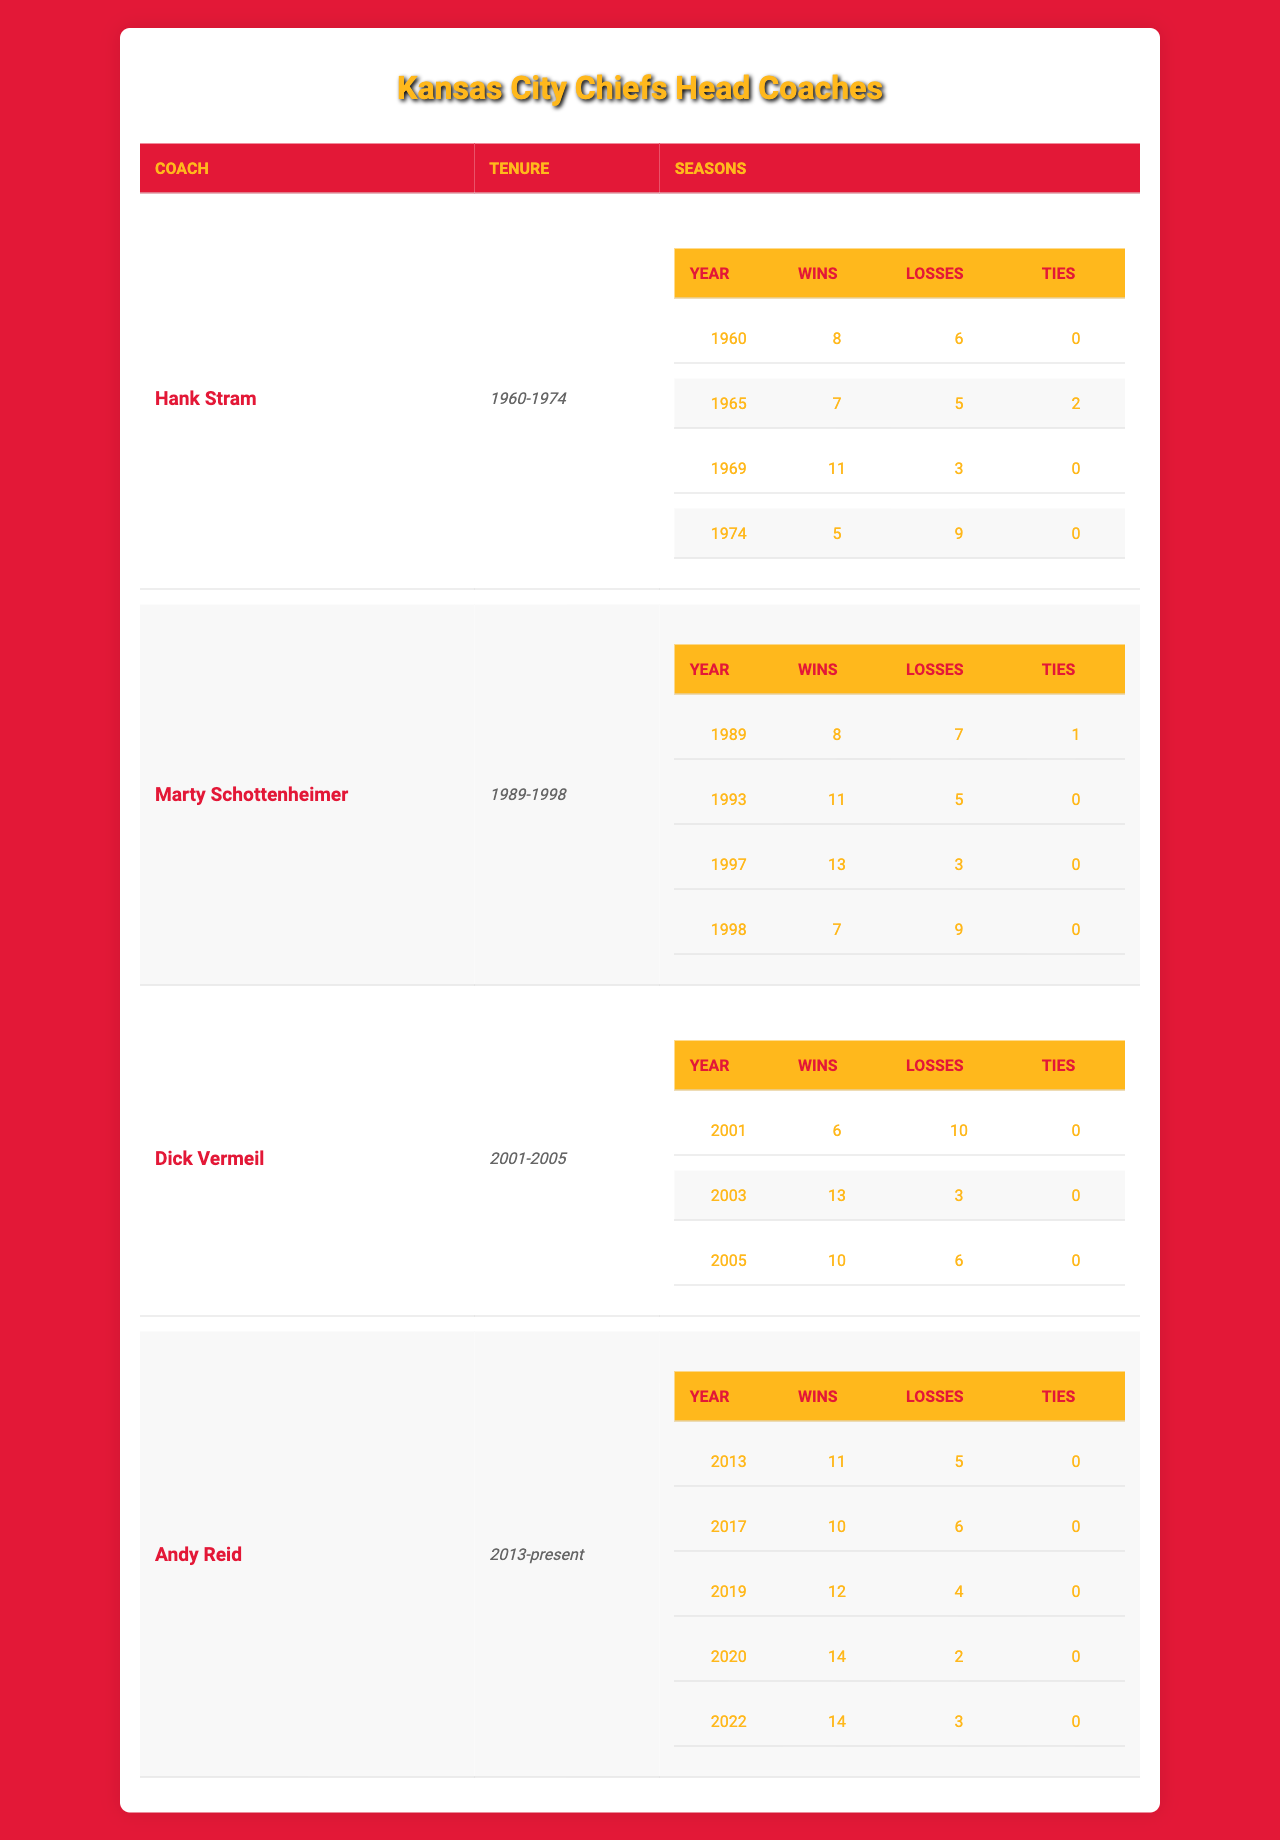What was the total number of wins for Hank Stram during his tenure? Hank Stram's tenure spans four seasons. The wins for each season are 8, 7, 11, and 5. By summing these numbers (8 + 7 + 11 + 5), we get a total of 31 wins.
Answer: 31 Which coach had the highest number of wins in a single season? Marty Schottenheimer had the highest number of wins in a single season with 13 wins in 1997.
Answer: 13 How many ties did the Kansas City Chiefs have during Dick Vermeil's tenure? Dick Vermeil's tenure includes three seasons, with ties recorded in 0, 0, and 0, resulting in a total of 0 ties.
Answer: 0 What was Andy Reid's total win-loss record from the years listed? Andy Reid's seasons include 11 wins and 5 losses (2013), 10 wins and 6 losses (2017), 12 wins and 4 losses (2019), 14 wins and 2 losses (2020), and 14 wins and 3 losses (2022). Total wins = 11 + 10 + 12 + 14 + 14 = 61 and total losses = 5 + 6 + 4 + 2 + 3 = 20. So, the total record is 61-20.
Answer: 61-20 What was the average number of wins per season for Marty Schottenheimer? Marty Schottenheimer's wins over four seasons are 8, 11, 13, and 7, totaling 39 wins. To find the average, we divide the total wins (39) by the number of seasons (4), resulting in an average of 9.75.
Answer: 9.75 Did any coach have a season with more losses than wins during their tenure? Looking at the seasons for each coach, Hank Stram had a season listed in 1974 with 5 wins and 9 losses, indicating that he had more losses than wins in that year.
Answer: Yes What was the combined number of wins for all coaches in years they had winning seasons? The winning seasons data show that Hank Stram had wins in 1960 (8), 1965 (7), 1969 (11), Marty Schottenheimer had wins in 1989 (8), 1993 (11), 1997 (13), Dick Vermeil had wins in 2003 (13), and Andy Reid had winning seasons with totals of 11 (2013), 10 (2017), 12 (2019), 14 (2020), and 14 (2022). All winning seasons summed equals 8 + 7 + 11 + 8 + 11 + 13 + 13 + 11 + 10 + 12 + 14 + 14 =  100.
Answer: 100 In what year did the Kansas City Chiefs have the fewest wins under any coach listed? In 2001, under Dick Vermeil, the Kansas City Chiefs had 6 wins, which is the fewest among all the win totals listed for the coaches.
Answer: 2001 